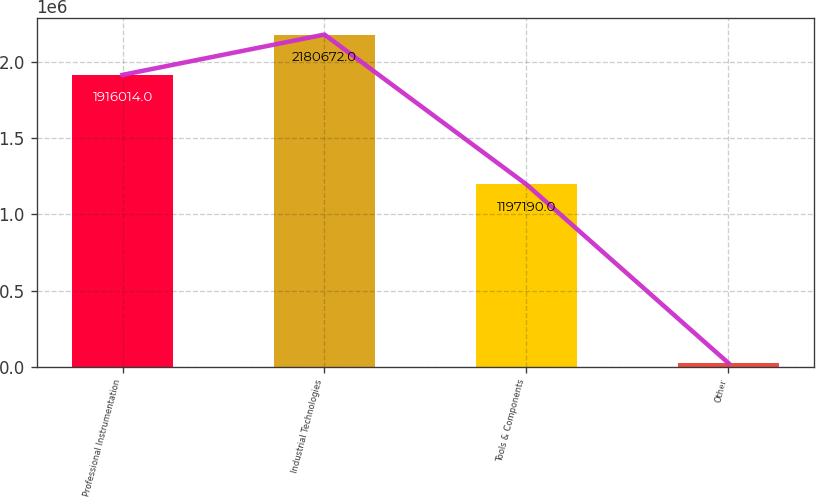Convert chart. <chart><loc_0><loc_0><loc_500><loc_500><bar_chart><fcel>Professional Instrumentation<fcel>Industrial Technologies<fcel>Tools & Components<fcel>Other<nl><fcel>1.91601e+06<fcel>2.18067e+06<fcel>1.19719e+06<fcel>24669<nl></chart> 